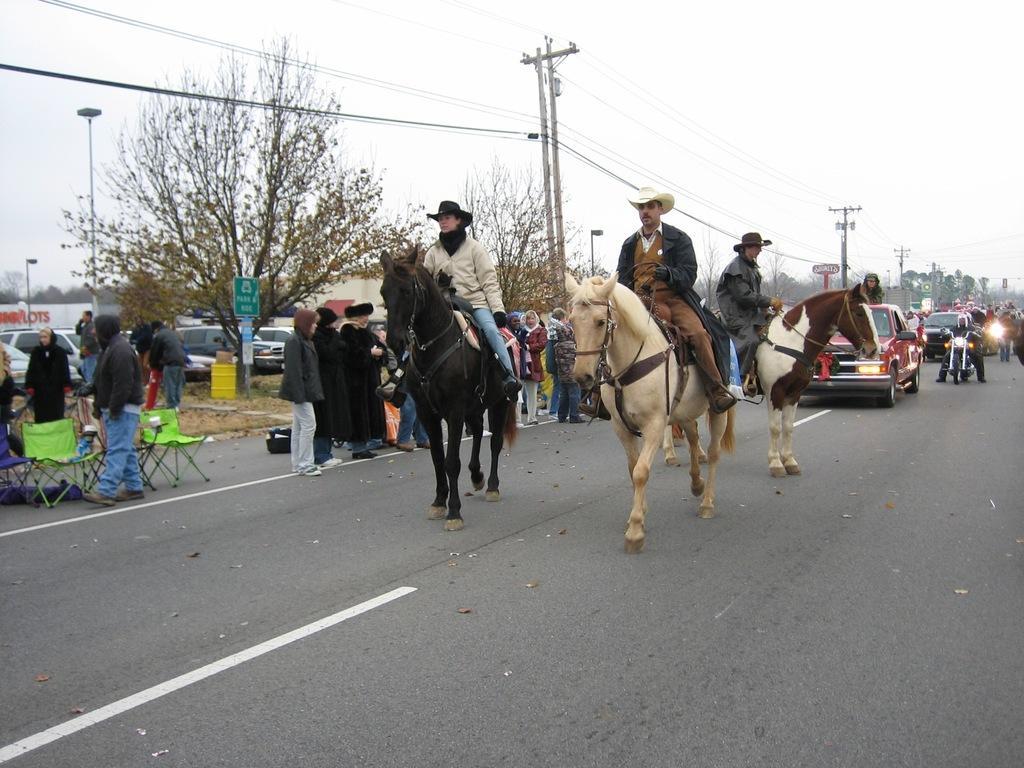How would you summarize this image in a sentence or two? In this image, I can see three persons sitting on the horses and vehicles on the road. There are groups of people standing, chairs, street lights, current poles with wires, trees, buildings, boards and cars, which are parked. In the background, there is the sky. 